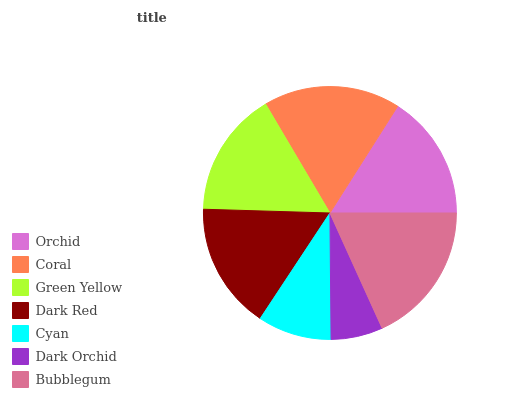Is Dark Orchid the minimum?
Answer yes or no. Yes. Is Bubblegum the maximum?
Answer yes or no. Yes. Is Coral the minimum?
Answer yes or no. No. Is Coral the maximum?
Answer yes or no. No. Is Coral greater than Orchid?
Answer yes or no. Yes. Is Orchid less than Coral?
Answer yes or no. Yes. Is Orchid greater than Coral?
Answer yes or no. No. Is Coral less than Orchid?
Answer yes or no. No. Is Green Yellow the high median?
Answer yes or no. Yes. Is Green Yellow the low median?
Answer yes or no. Yes. Is Dark Orchid the high median?
Answer yes or no. No. Is Dark Red the low median?
Answer yes or no. No. 